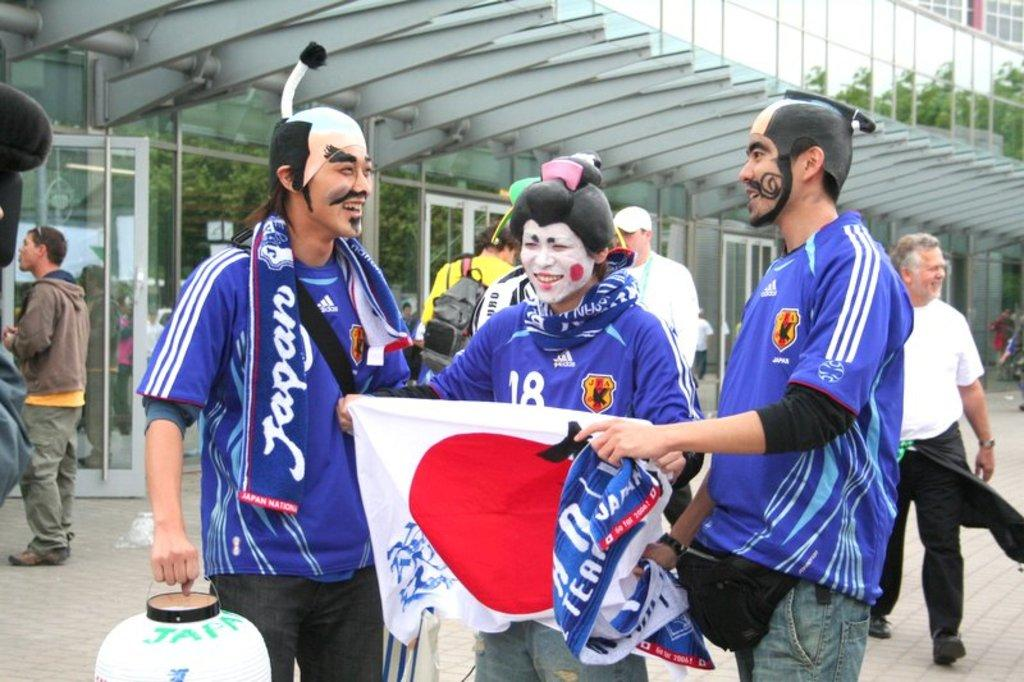How many people are in the image? There are people in the image, specifically three persons. What are the three persons doing in the image? The three persons are holding objects, and they are smiling. Can you describe the objects in the background? There are glass objects in the background. What else can be seen in the background? Trees are present in the background. What type of drain can be seen in the image? There is no drain present in the image. How many plates are visible on the top of the table in the image? There is no table or plates mentioned in the provided facts, so we cannot answer this question. 